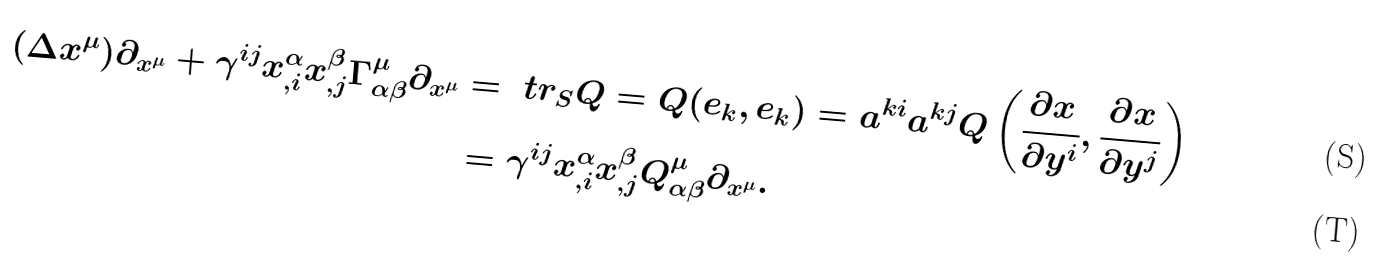<formula> <loc_0><loc_0><loc_500><loc_500>( \Delta x ^ { \mu } ) \partial _ { x ^ { \mu } } + \gamma ^ { i j } x _ { , i } ^ { \alpha } x _ { , j } ^ { \beta } \Gamma _ { \alpha \beta } ^ { \mu } \partial _ { x ^ { \mu } } & = \ t r _ { S } Q = Q ( e _ { k } , e _ { k } ) = a ^ { k i } a ^ { k j } Q \left ( \frac { \partial x } { \partial y ^ { i } } , \frac { \partial x } { \partial y ^ { j } } \right ) \\ & = \gamma ^ { i j } x _ { , i } ^ { \alpha } x _ { , j } ^ { \beta } Q _ { \alpha \beta } ^ { \mu } \partial _ { x ^ { \mu } } .</formula> 